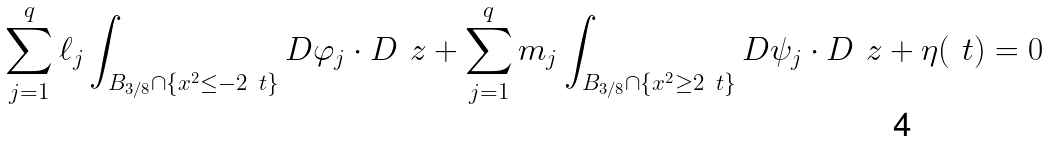<formula> <loc_0><loc_0><loc_500><loc_500>\sum _ { j = 1 } ^ { q } \ell _ { j } \int _ { B _ { 3 / 8 } \cap \{ x ^ { 2 } \leq - 2 \ t \} } D \varphi _ { j } \cdot D \ z + \sum _ { j = 1 } ^ { q } m _ { j } \int _ { B _ { 3 / 8 } \cap \{ x ^ { 2 } \geq 2 \ t \} } D \psi _ { j } \cdot D \ z + \eta ( \ t ) = 0</formula> 